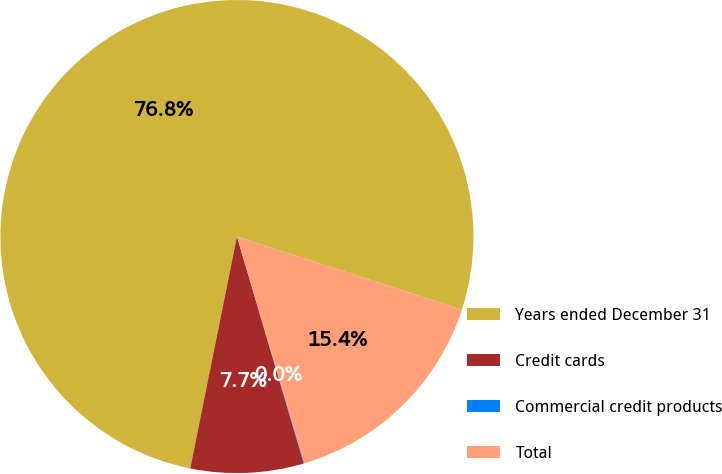Convert chart. <chart><loc_0><loc_0><loc_500><loc_500><pie_chart><fcel>Years ended December 31<fcel>Credit cards<fcel>Commercial credit products<fcel>Total<nl><fcel>76.84%<fcel>7.72%<fcel>0.04%<fcel>15.4%<nl></chart> 